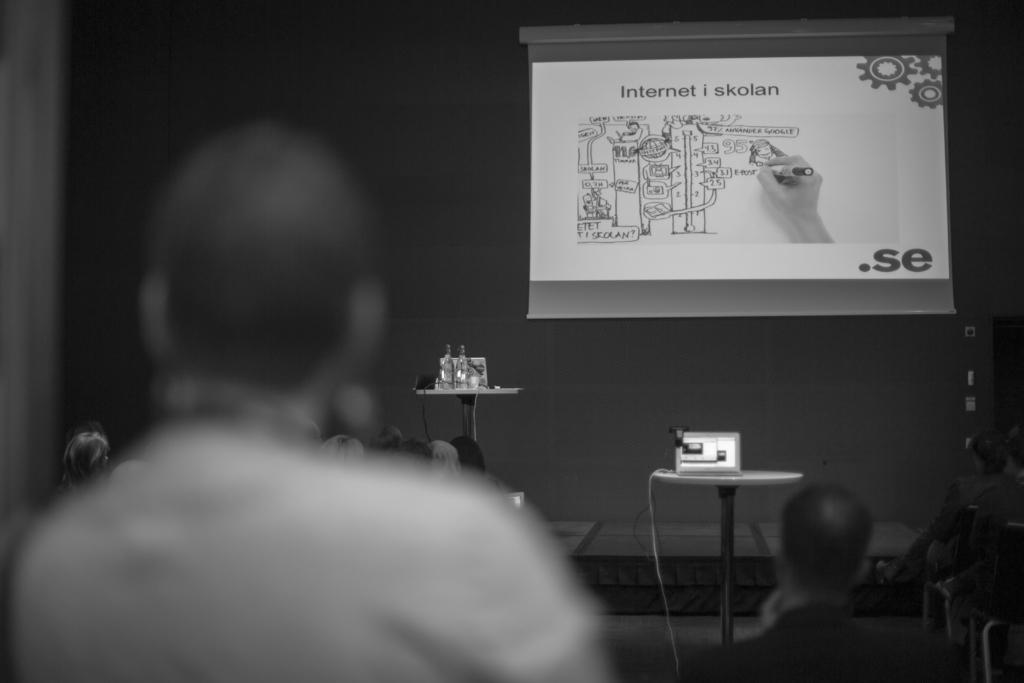Who is present in the image? There is a person in the image. Can you describe the surroundings of the person? There are people in the background of the image, along with a wall, a projection screen, and a projector. What is being displayed on the projection screen? There is a projection on the projection screen. What type of horn can be seen on the person in the image? There is no horn present on the person in the image. How many children are visible in the image? There is no mention of children in the provided facts, so we cannot determine their presence in the image. 